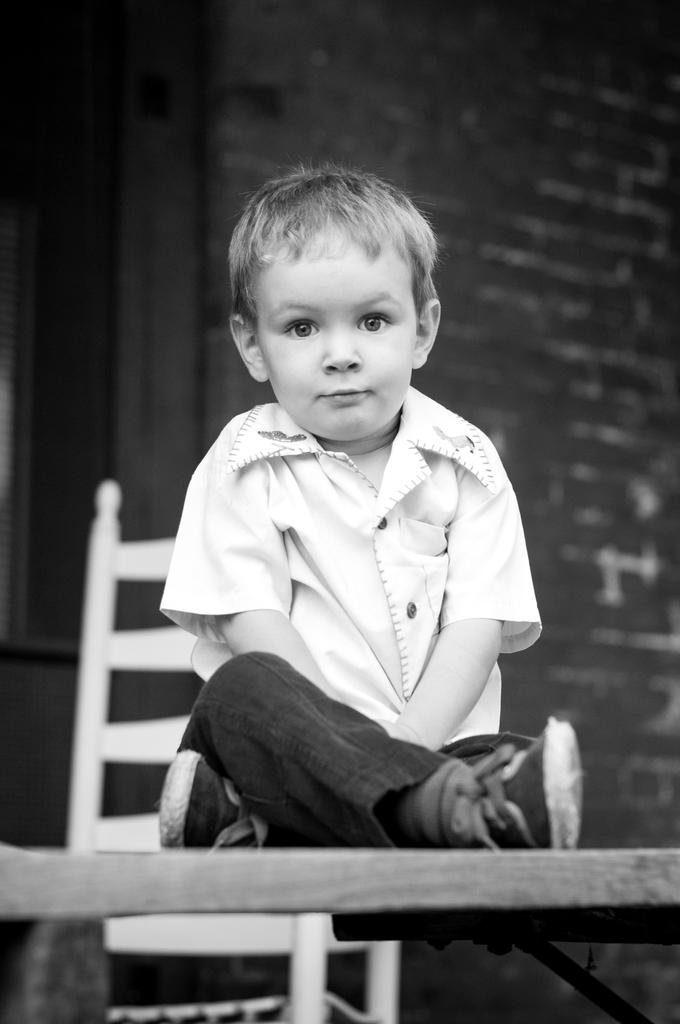Who is the main subject in the image? There is a boy in the image. What is the boy doing in the image? The boy is sitting on a table. Is there any furniture in the image? Yes, there is a chair in the image. What can be seen in the background of the image? There is a building in the background of the image. What type of turkey can be seen flying in the background of the image? There is no turkey present in the image, let alone a flying one. 